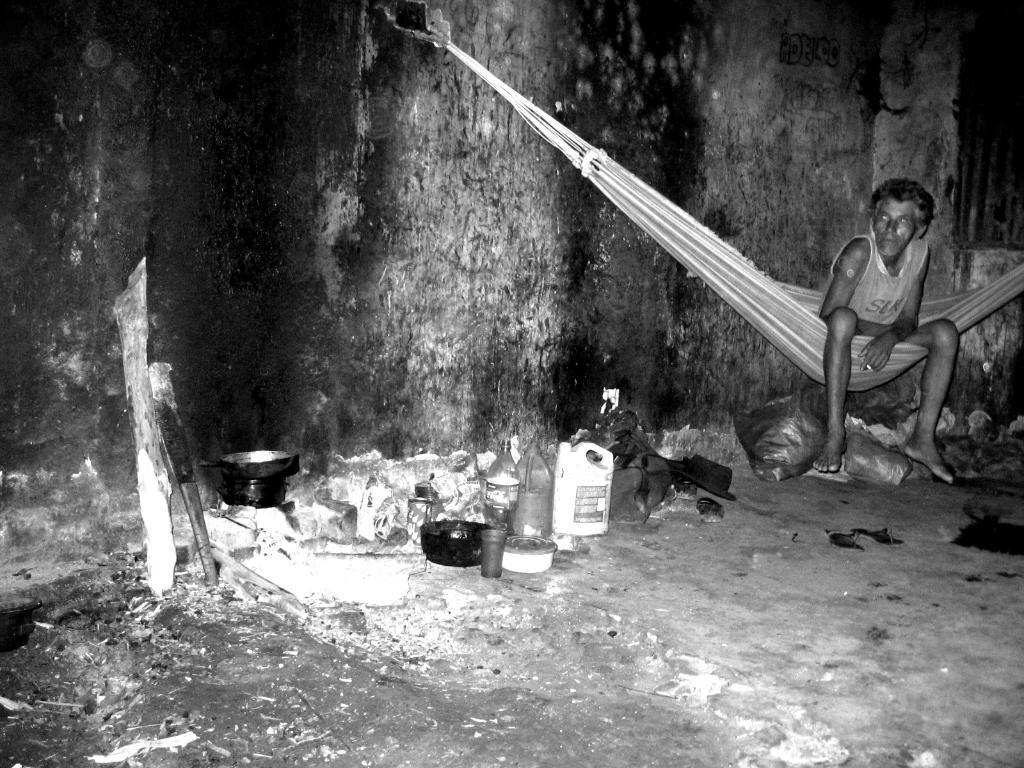Could you give a brief overview of what you see in this image? In this image I can see the black and white picture. I can see the ground, a person sitting, on the ground I can see a bowl, a glass, few cans, few bags and few other objects. 